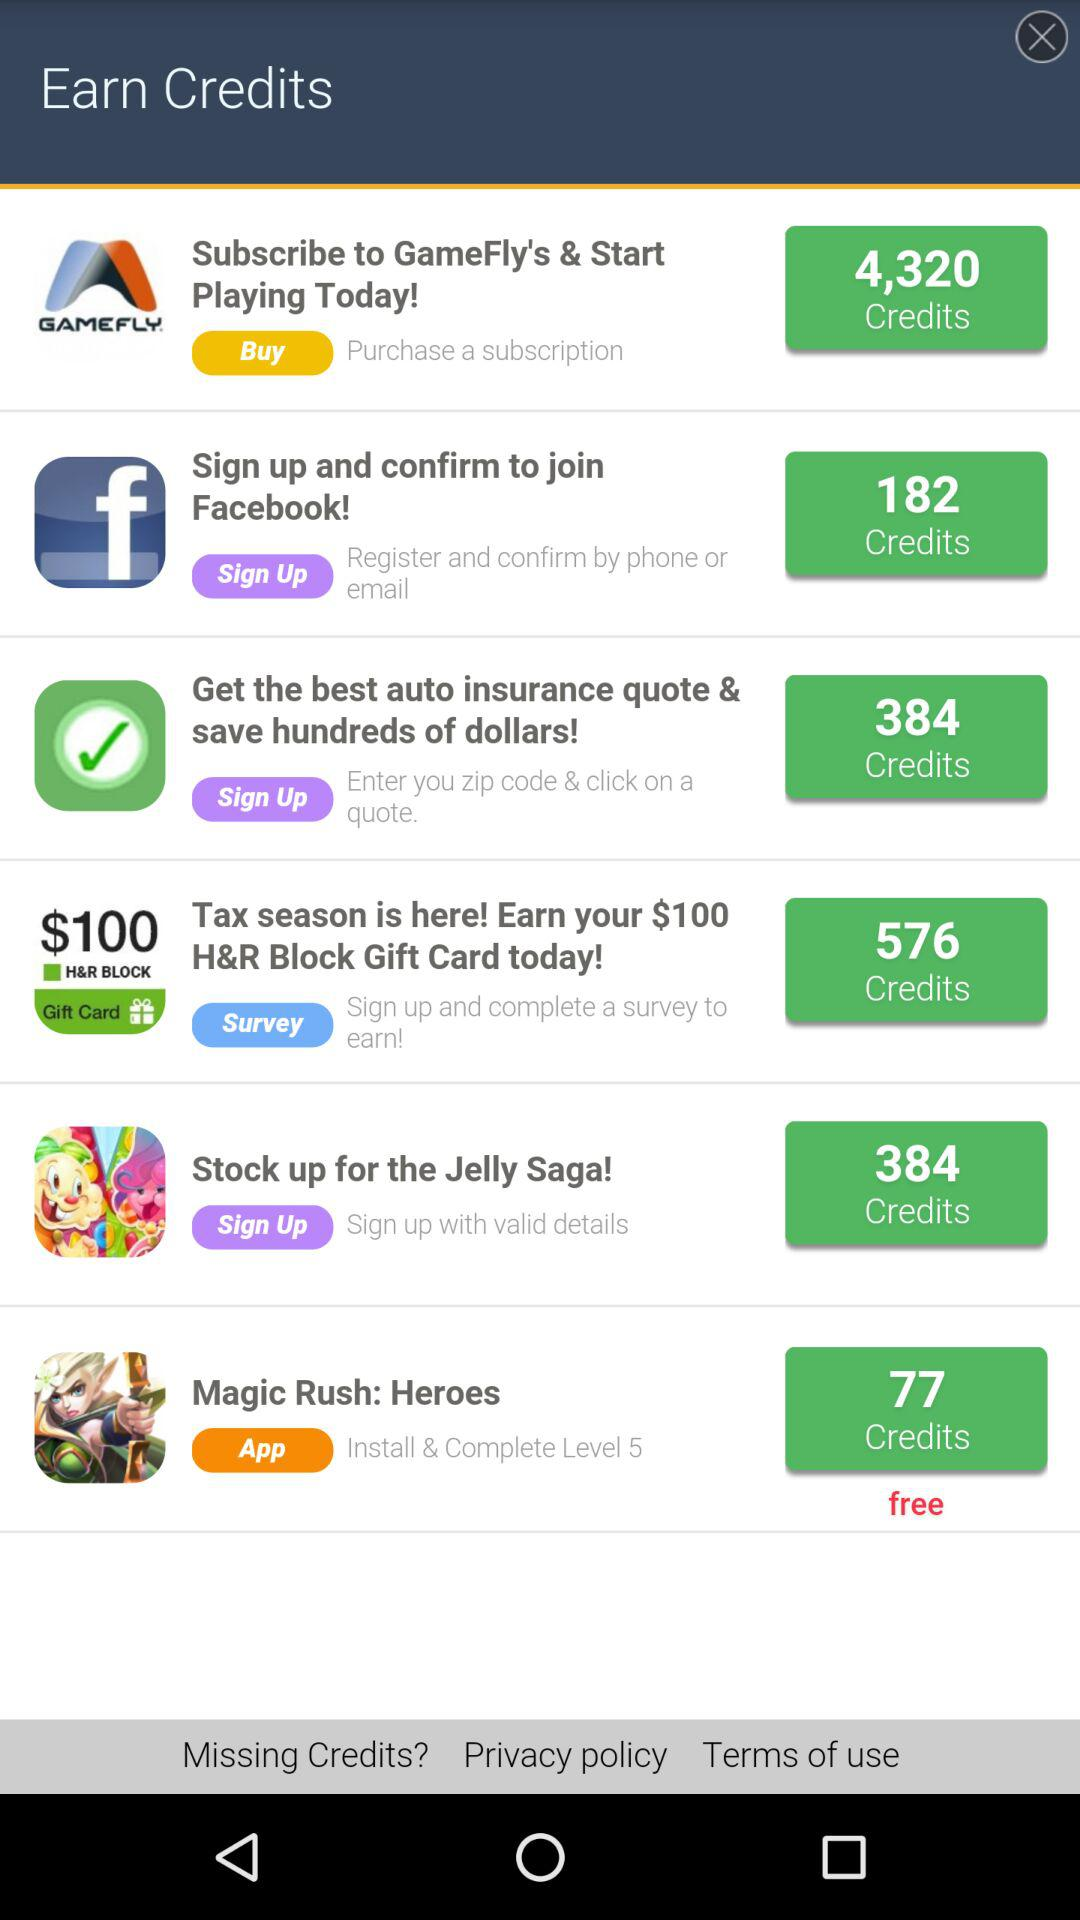What's the application name which is free and the user can earn 77 Credits? The application name is "Magic Rush: Heroes". 